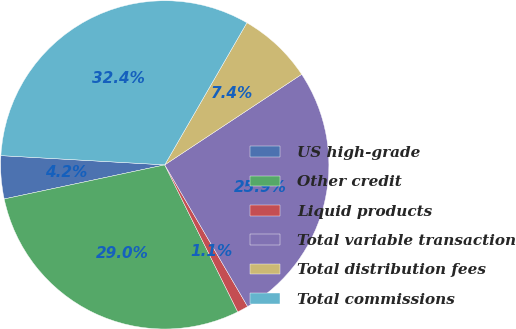<chart> <loc_0><loc_0><loc_500><loc_500><pie_chart><fcel>US high-grade<fcel>Other credit<fcel>Liquid products<fcel>Total variable transaction<fcel>Total distribution fees<fcel>Total commissions<nl><fcel>4.23%<fcel>29.0%<fcel>1.09%<fcel>25.87%<fcel>7.36%<fcel>32.44%<nl></chart> 